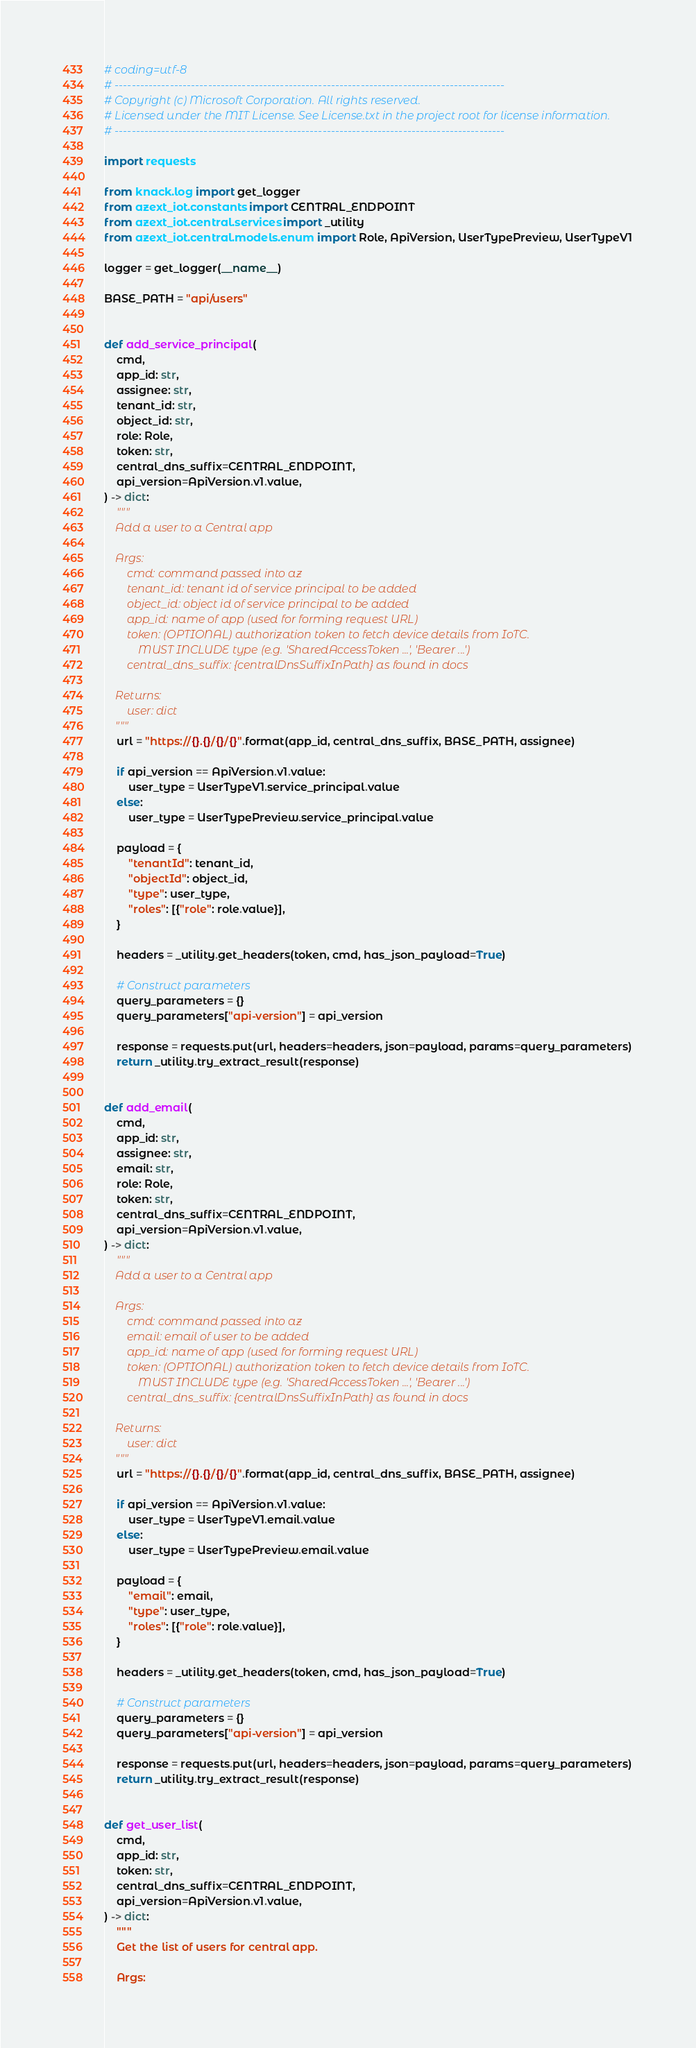<code> <loc_0><loc_0><loc_500><loc_500><_Python_># coding=utf-8
# --------------------------------------------------------------------------------------------
# Copyright (c) Microsoft Corporation. All rights reserved.
# Licensed under the MIT License. See License.txt in the project root for license information.
# --------------------------------------------------------------------------------------------

import requests

from knack.log import get_logger
from azext_iot.constants import CENTRAL_ENDPOINT
from azext_iot.central.services import _utility
from azext_iot.central.models.enum import Role, ApiVersion, UserTypePreview, UserTypeV1

logger = get_logger(__name__)

BASE_PATH = "api/users"


def add_service_principal(
    cmd,
    app_id: str,
    assignee: str,
    tenant_id: str,
    object_id: str,
    role: Role,
    token: str,
    central_dns_suffix=CENTRAL_ENDPOINT,
    api_version=ApiVersion.v1.value,
) -> dict:
    """
    Add a user to a Central app

    Args:
        cmd: command passed into az
        tenant_id: tenant id of service principal to be added
        object_id: object id of service principal to be added
        app_id: name of app (used for forming request URL)
        token: (OPTIONAL) authorization token to fetch device details from IoTC.
            MUST INCLUDE type (e.g. 'SharedAccessToken ...', 'Bearer ...')
        central_dns_suffix: {centralDnsSuffixInPath} as found in docs

    Returns:
        user: dict
    """
    url = "https://{}.{}/{}/{}".format(app_id, central_dns_suffix, BASE_PATH, assignee)

    if api_version == ApiVersion.v1.value:
        user_type = UserTypeV1.service_principal.value
    else:
        user_type = UserTypePreview.service_principal.value

    payload = {
        "tenantId": tenant_id,
        "objectId": object_id,
        "type": user_type,
        "roles": [{"role": role.value}],
    }

    headers = _utility.get_headers(token, cmd, has_json_payload=True)

    # Construct parameters
    query_parameters = {}
    query_parameters["api-version"] = api_version

    response = requests.put(url, headers=headers, json=payload, params=query_parameters)
    return _utility.try_extract_result(response)


def add_email(
    cmd,
    app_id: str,
    assignee: str,
    email: str,
    role: Role,
    token: str,
    central_dns_suffix=CENTRAL_ENDPOINT,
    api_version=ApiVersion.v1.value,
) -> dict:
    """
    Add a user to a Central app

    Args:
        cmd: command passed into az
        email: email of user to be added
        app_id: name of app (used for forming request URL)
        token: (OPTIONAL) authorization token to fetch device details from IoTC.
            MUST INCLUDE type (e.g. 'SharedAccessToken ...', 'Bearer ...')
        central_dns_suffix: {centralDnsSuffixInPath} as found in docs

    Returns:
        user: dict
    """
    url = "https://{}.{}/{}/{}".format(app_id, central_dns_suffix, BASE_PATH, assignee)

    if api_version == ApiVersion.v1.value:
        user_type = UserTypeV1.email.value
    else:
        user_type = UserTypePreview.email.value

    payload = {
        "email": email,
        "type": user_type,
        "roles": [{"role": role.value}],
    }

    headers = _utility.get_headers(token, cmd, has_json_payload=True)

    # Construct parameters
    query_parameters = {}
    query_parameters["api-version"] = api_version

    response = requests.put(url, headers=headers, json=payload, params=query_parameters)
    return _utility.try_extract_result(response)


def get_user_list(
    cmd,
    app_id: str,
    token: str,
    central_dns_suffix=CENTRAL_ENDPOINT,
    api_version=ApiVersion.v1.value,
) -> dict:
    """
    Get the list of users for central app.

    Args:</code> 